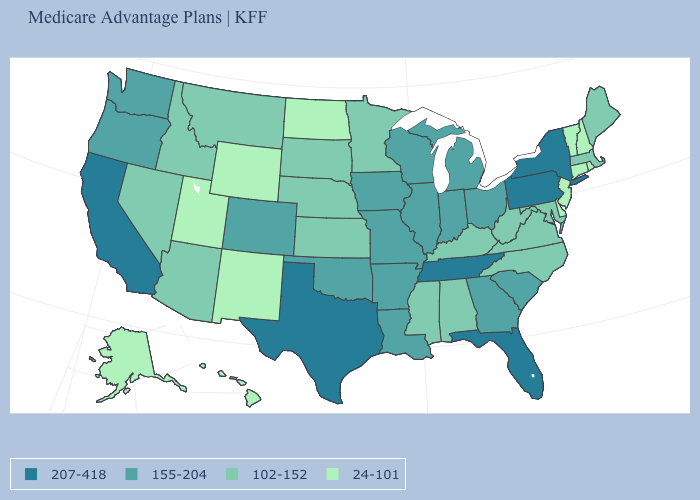Among the states that border Rhode Island , does Connecticut have the lowest value?
Give a very brief answer. Yes. Among the states that border Maryland , which have the highest value?
Concise answer only. Pennsylvania. What is the value of Nebraska?
Answer briefly. 102-152. What is the value of North Carolina?
Write a very short answer. 102-152. Which states have the highest value in the USA?
Keep it brief. California, Florida, New York, Pennsylvania, Tennessee, Texas. Name the states that have a value in the range 155-204?
Short answer required. Arkansas, Colorado, Georgia, Iowa, Illinois, Indiana, Louisiana, Michigan, Missouri, Ohio, Oklahoma, Oregon, South Carolina, Washington, Wisconsin. Does Oklahoma have the highest value in the USA?
Short answer required. No. What is the lowest value in the USA?
Concise answer only. 24-101. What is the highest value in states that border Connecticut?
Keep it brief. 207-418. Does Ohio have a higher value than Maryland?
Give a very brief answer. Yes. Is the legend a continuous bar?
Concise answer only. No. What is the value of Texas?
Write a very short answer. 207-418. Does Michigan have the lowest value in the MidWest?
Short answer required. No. Name the states that have a value in the range 155-204?
Keep it brief. Arkansas, Colorado, Georgia, Iowa, Illinois, Indiana, Louisiana, Michigan, Missouri, Ohio, Oklahoma, Oregon, South Carolina, Washington, Wisconsin. Name the states that have a value in the range 102-152?
Concise answer only. Alabama, Arizona, Idaho, Kansas, Kentucky, Massachusetts, Maryland, Maine, Minnesota, Mississippi, Montana, North Carolina, Nebraska, Nevada, South Dakota, Virginia, West Virginia. 